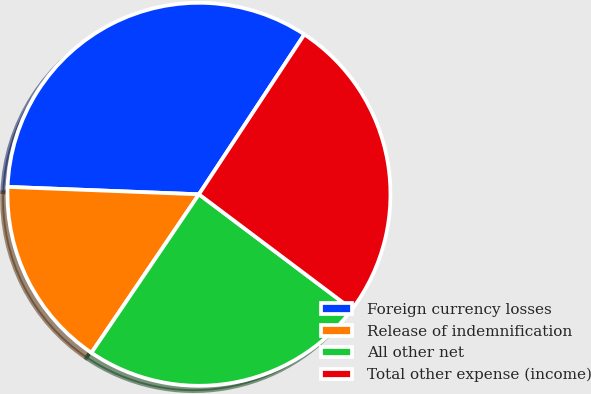Convert chart to OTSL. <chart><loc_0><loc_0><loc_500><loc_500><pie_chart><fcel>Foreign currency losses<fcel>Release of indemnification<fcel>All other net<fcel>Total other expense (income)<nl><fcel>33.66%<fcel>16.13%<fcel>24.23%<fcel>25.98%<nl></chart> 